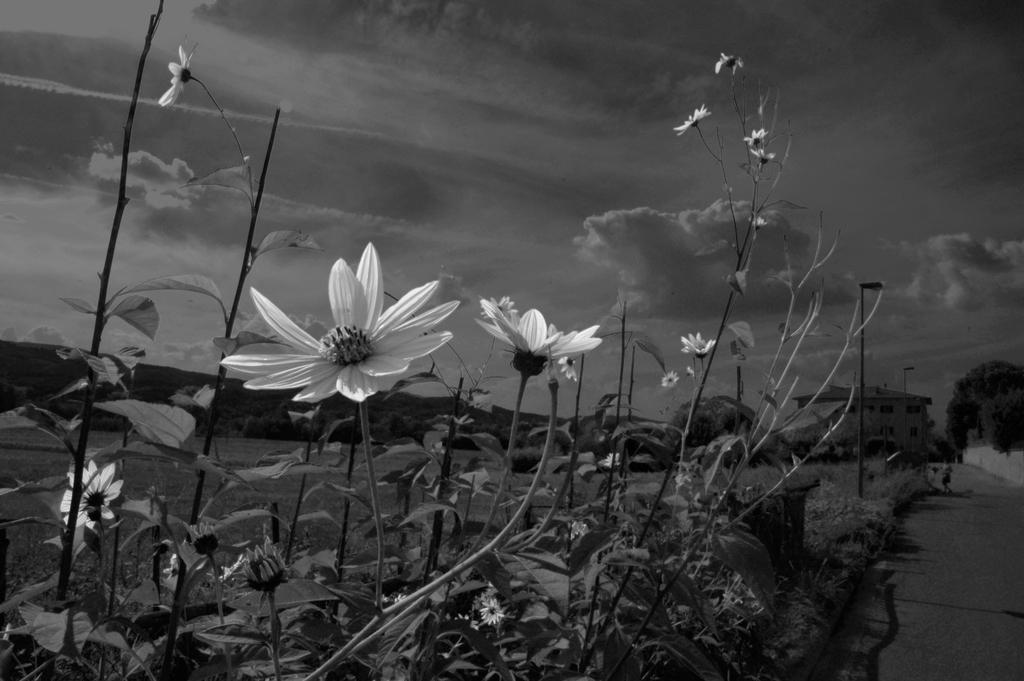What is the condition of the sky in the image? The sky is cloudy in the image. What type of vegetation can be seen in the image? There are plants with flowers in the image. What structures are visible in the distance? There is a building and a light pole in the distance. What type of natural element is present in the distance? There is a tree in the distance. How many fangs can be seen on the tree in the image? There are no fangs present in the image; it features a tree without any fangs. What type of crate is visible in the image? There is no crate present in the image. 